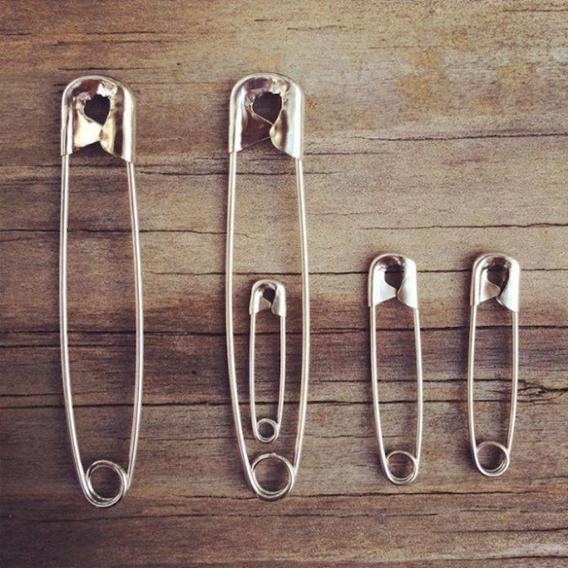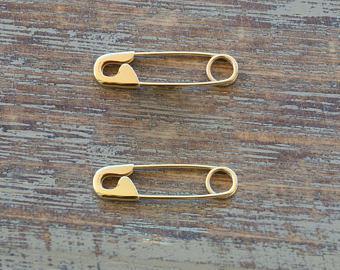The first image is the image on the left, the second image is the image on the right. Given the left and right images, does the statement "The safety pins have numbers on them." hold true? Answer yes or no. No. The first image is the image on the left, the second image is the image on the right. Assess this claim about the two images: "One image contains exactly two gold-colored safety pins displayed horizontally.". Correct or not? Answer yes or no. Yes. 